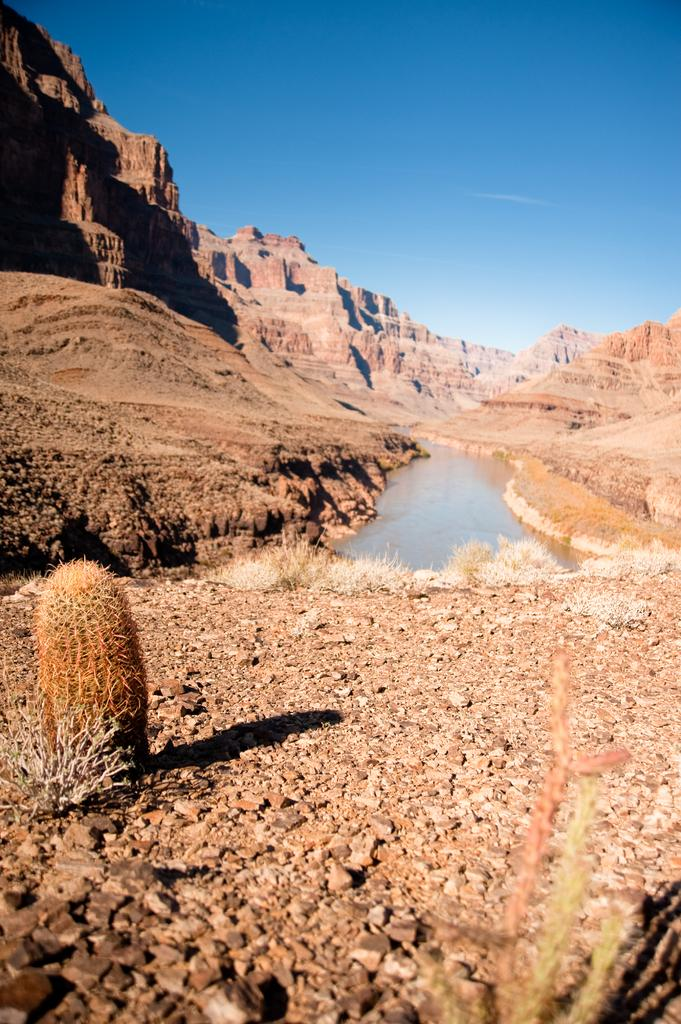What type of natural elements can be seen in the image? There are plants, rocky mountains, and a lake in the image. What is the color and condition of the sky in the image? The sky is blue and clear in the image. What type of pancake is being served at the place in the image? There is no place or pancake present in the image; it features natural elements such as plants, rocky mountains, and a lake. Is there a hat visible on anyone in the image? There are no people or hats present in the image. 